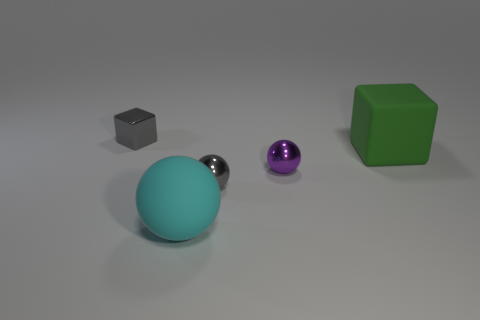Do the purple metal object and the large green thing have the same shape?
Ensure brevity in your answer.  No. There is a gray thing that is the same shape as the green thing; what size is it?
Keep it short and to the point. Small. There is a thing that is both in front of the large green matte object and on the right side of the gray metal ball; how big is it?
Offer a very short reply. Small. There is a thing that is the same color as the metallic block; what is it made of?
Keep it short and to the point. Metal. How many shiny objects are the same color as the tiny cube?
Your answer should be compact. 1. There is a ball that is made of the same material as the green thing; what is its size?
Provide a short and direct response. Large. The other ball that is the same material as the tiny purple ball is what color?
Offer a very short reply. Gray. What is the material of the large cyan object that is the same shape as the purple shiny object?
Your answer should be compact. Rubber. What shape is the gray metal object that is the same size as the gray metallic block?
Your response must be concise. Sphere. How many cylinders are gray things or green rubber things?
Provide a short and direct response. 0. 